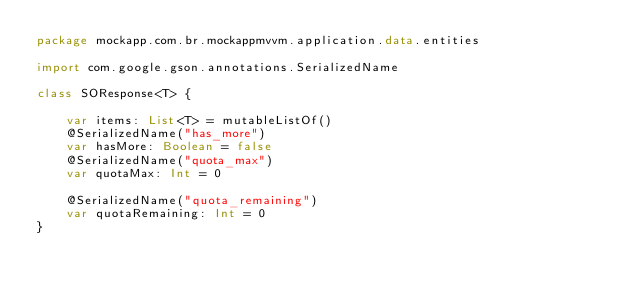<code> <loc_0><loc_0><loc_500><loc_500><_Kotlin_>package mockapp.com.br.mockappmvvm.application.data.entities

import com.google.gson.annotations.SerializedName

class SOResponse<T> {

    var items: List<T> = mutableListOf()
    @SerializedName("has_more")
    var hasMore: Boolean = false
    @SerializedName("quota_max")
    var quotaMax: Int = 0

    @SerializedName("quota_remaining")
    var quotaRemaining: Int = 0
}
</code> 